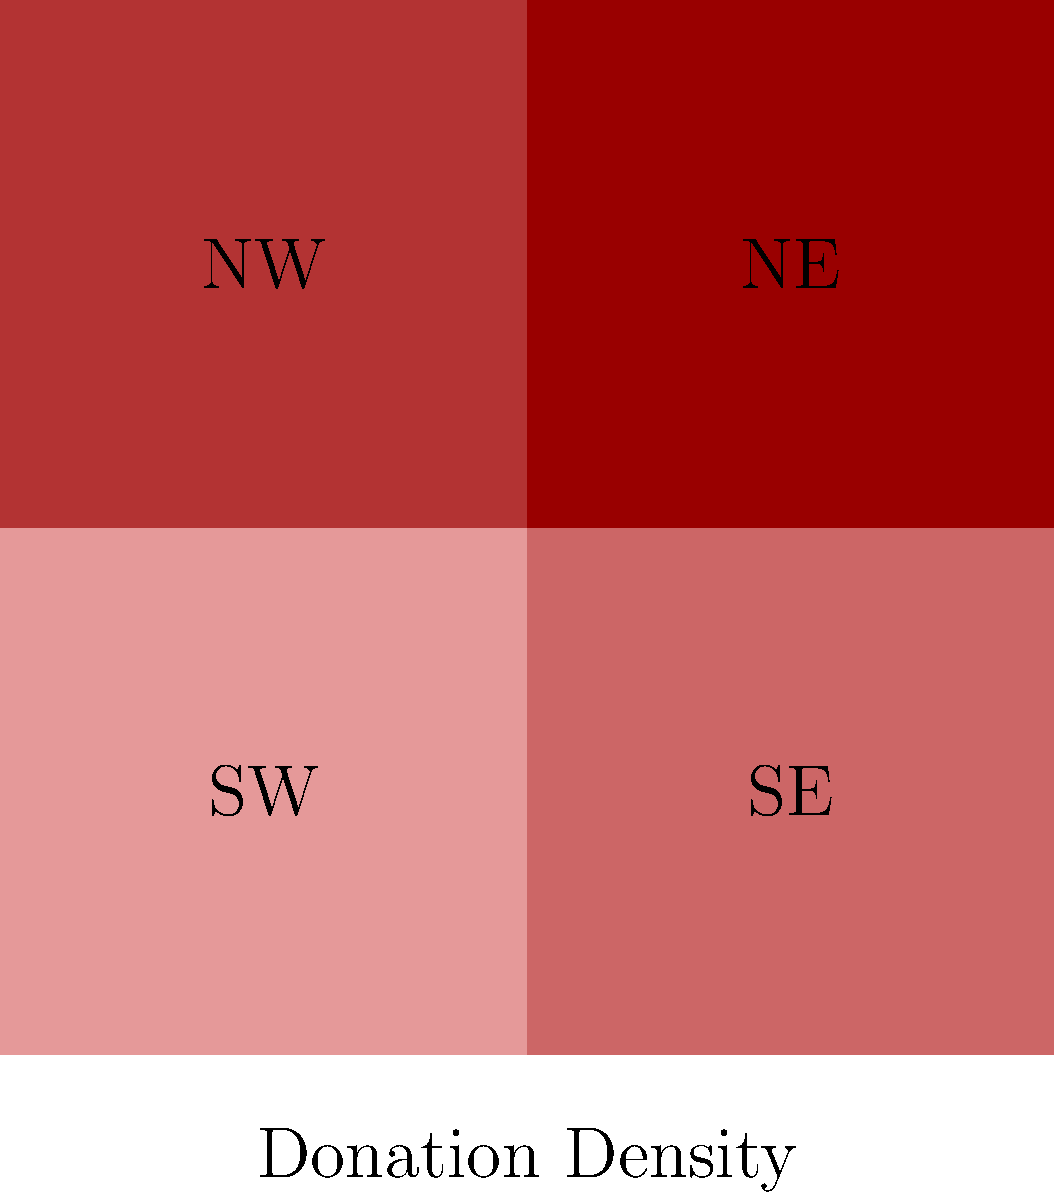Based on the color-coded map of donor distribution, which region shows the highest concentration of donors for your local charity? How might this information influence your fundraising strategy? To answer this question, we need to analyze the color-coded map:

1. The map is divided into four regions: NW (Northwest), NE (Northeast), SW (Southwest), and SE (Southeast).

2. The color intensity represents the concentration of donors, with darker shades indicating a higher concentration.

3. Examining the colors:
   - NW (top-left): Light red
   - NE (top-right): Medium-light red
   - SW (bottom-left): Medium-dark red
   - SE (bottom-right): Dark red

4. The SE (Southeast) region has the darkest shade of red, indicating the highest concentration of donors.

5. This information can influence the fundraising strategy in several ways:
   a) Focus more resources on maintaining and expanding relationships with donors in the SE region.
   b) Investigate the factors contributing to the high donor concentration in the SE and attempt to replicate these conditions in other regions.
   c) Develop targeted campaigns to increase donor participation in less active regions, particularly the NW.
   d) Consider allocating more time and personnel to events and outreach activities in the SE region.
   e) Use the success in the SE as a case study to attract more ethical suppliers and donors in other regions.
Answer: Southeast (SE); focus resources on maintaining SE donors while developing strategies to increase participation in other regions. 